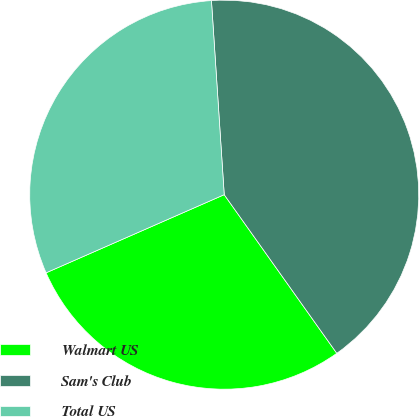Convert chart. <chart><loc_0><loc_0><loc_500><loc_500><pie_chart><fcel>Walmart US<fcel>Sam's Club<fcel>Total US<nl><fcel>28.24%<fcel>41.22%<fcel>30.53%<nl></chart> 